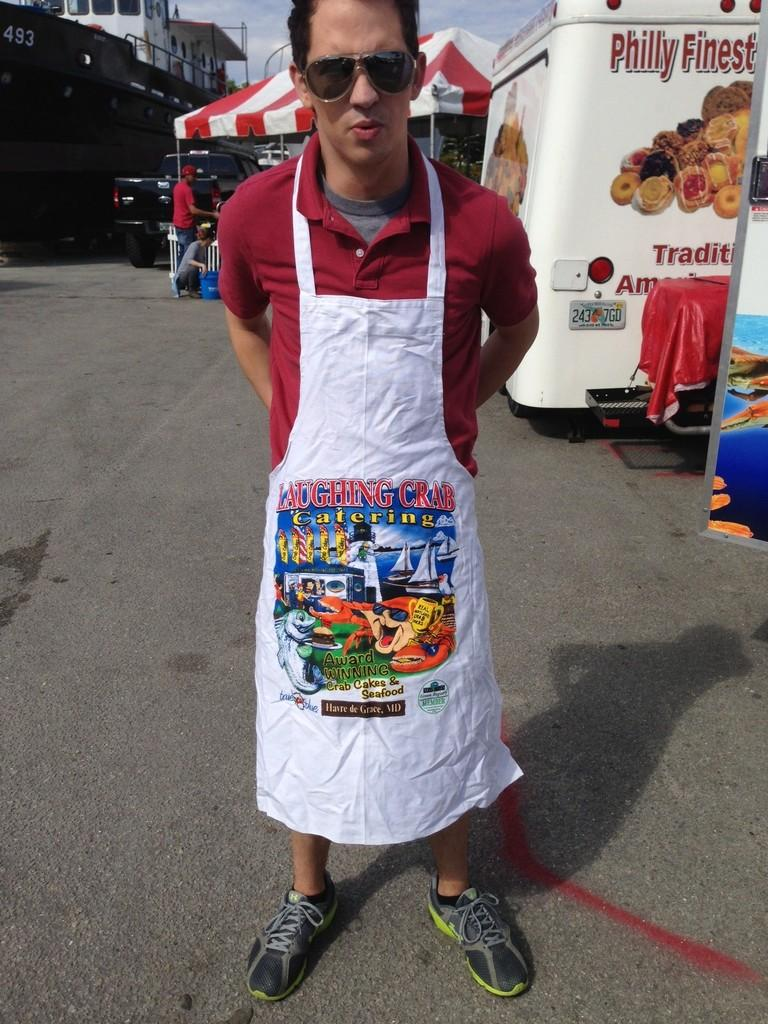<image>
Give a short and clear explanation of the subsequent image. a person wearing an apron from Laughing Crab Catering is at a festival 